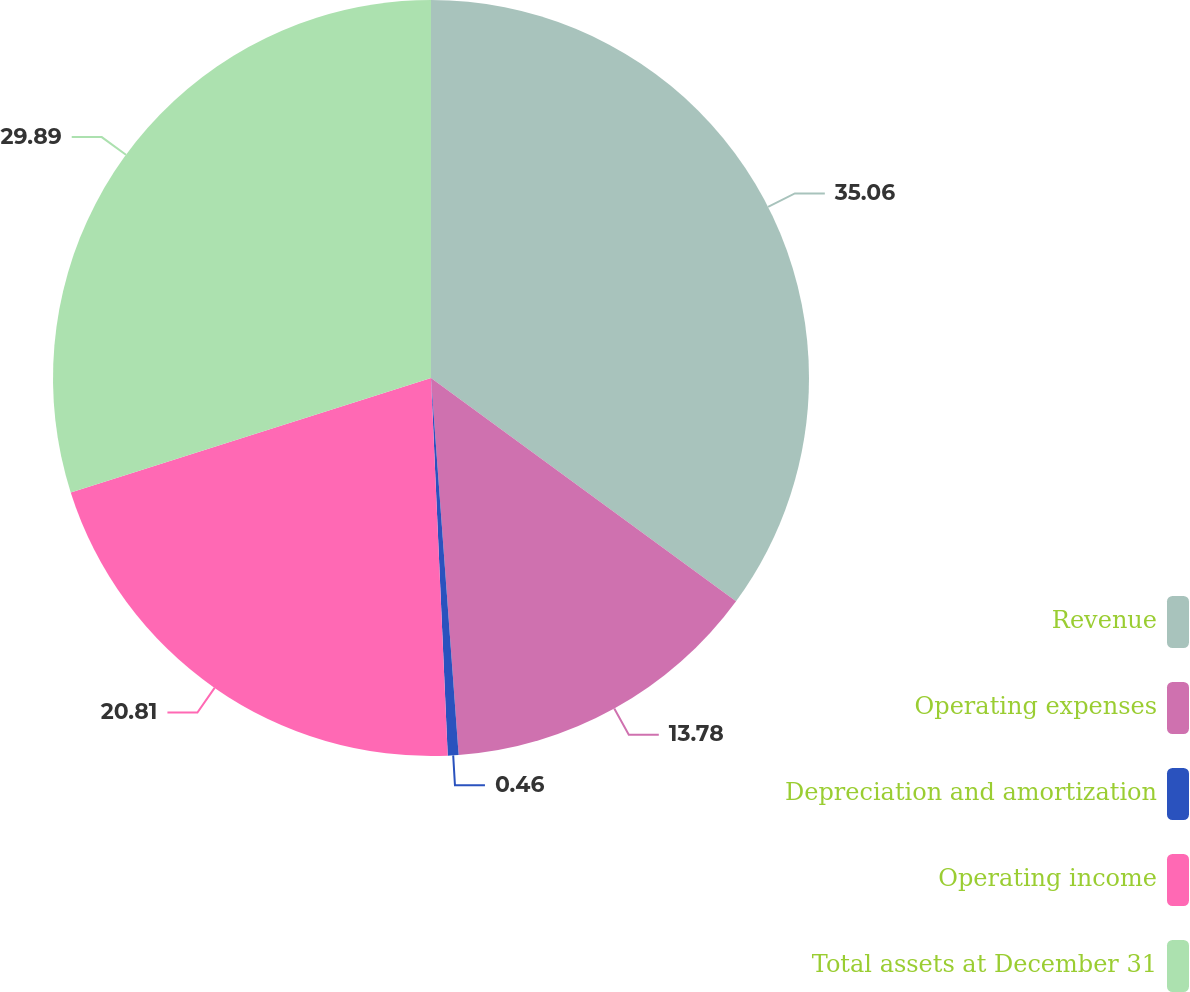Convert chart. <chart><loc_0><loc_0><loc_500><loc_500><pie_chart><fcel>Revenue<fcel>Operating expenses<fcel>Depreciation and amortization<fcel>Operating income<fcel>Total assets at December 31<nl><fcel>35.05%<fcel>13.78%<fcel>0.46%<fcel>20.81%<fcel>29.89%<nl></chart> 